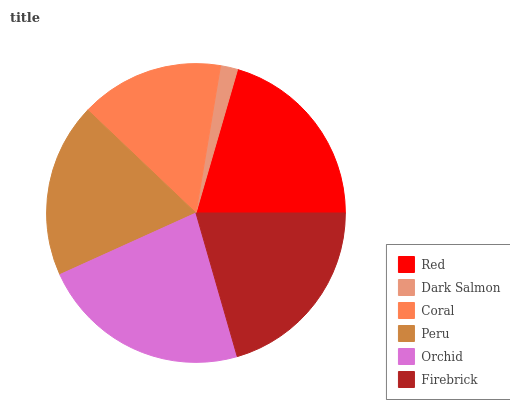Is Dark Salmon the minimum?
Answer yes or no. Yes. Is Orchid the maximum?
Answer yes or no. Yes. Is Coral the minimum?
Answer yes or no. No. Is Coral the maximum?
Answer yes or no. No. Is Coral greater than Dark Salmon?
Answer yes or no. Yes. Is Dark Salmon less than Coral?
Answer yes or no. Yes. Is Dark Salmon greater than Coral?
Answer yes or no. No. Is Coral less than Dark Salmon?
Answer yes or no. No. Is Red the high median?
Answer yes or no. Yes. Is Peru the low median?
Answer yes or no. Yes. Is Peru the high median?
Answer yes or no. No. Is Red the low median?
Answer yes or no. No. 